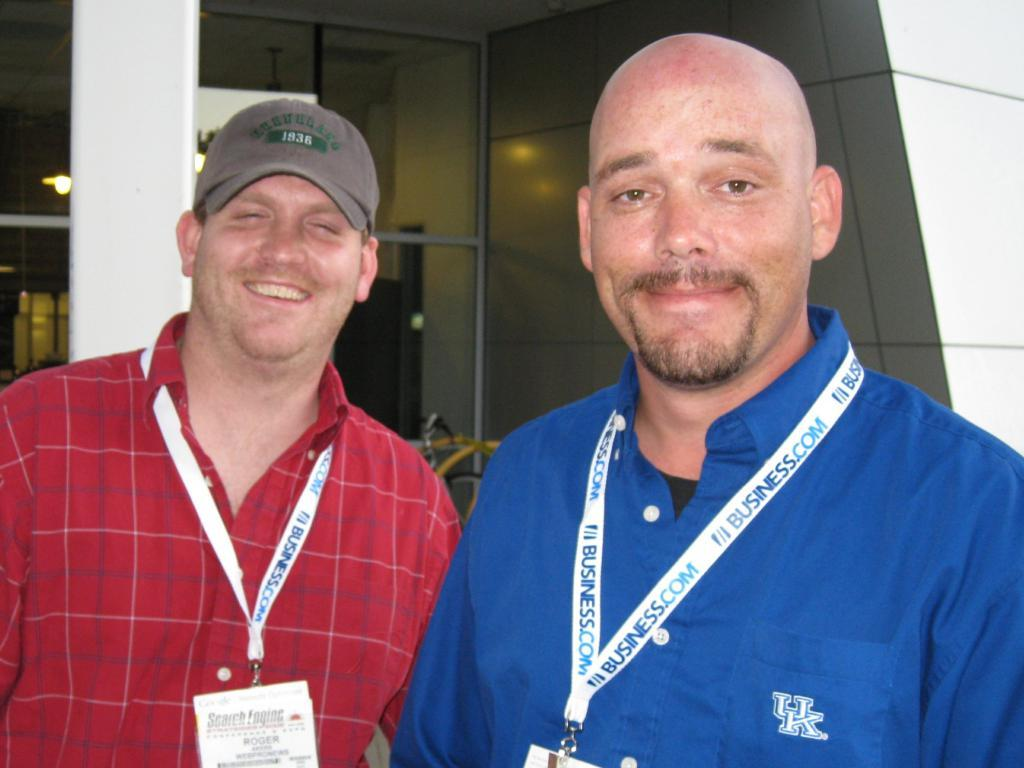<image>
Create a compact narrative representing the image presented. a man with an item around his neck that says business 